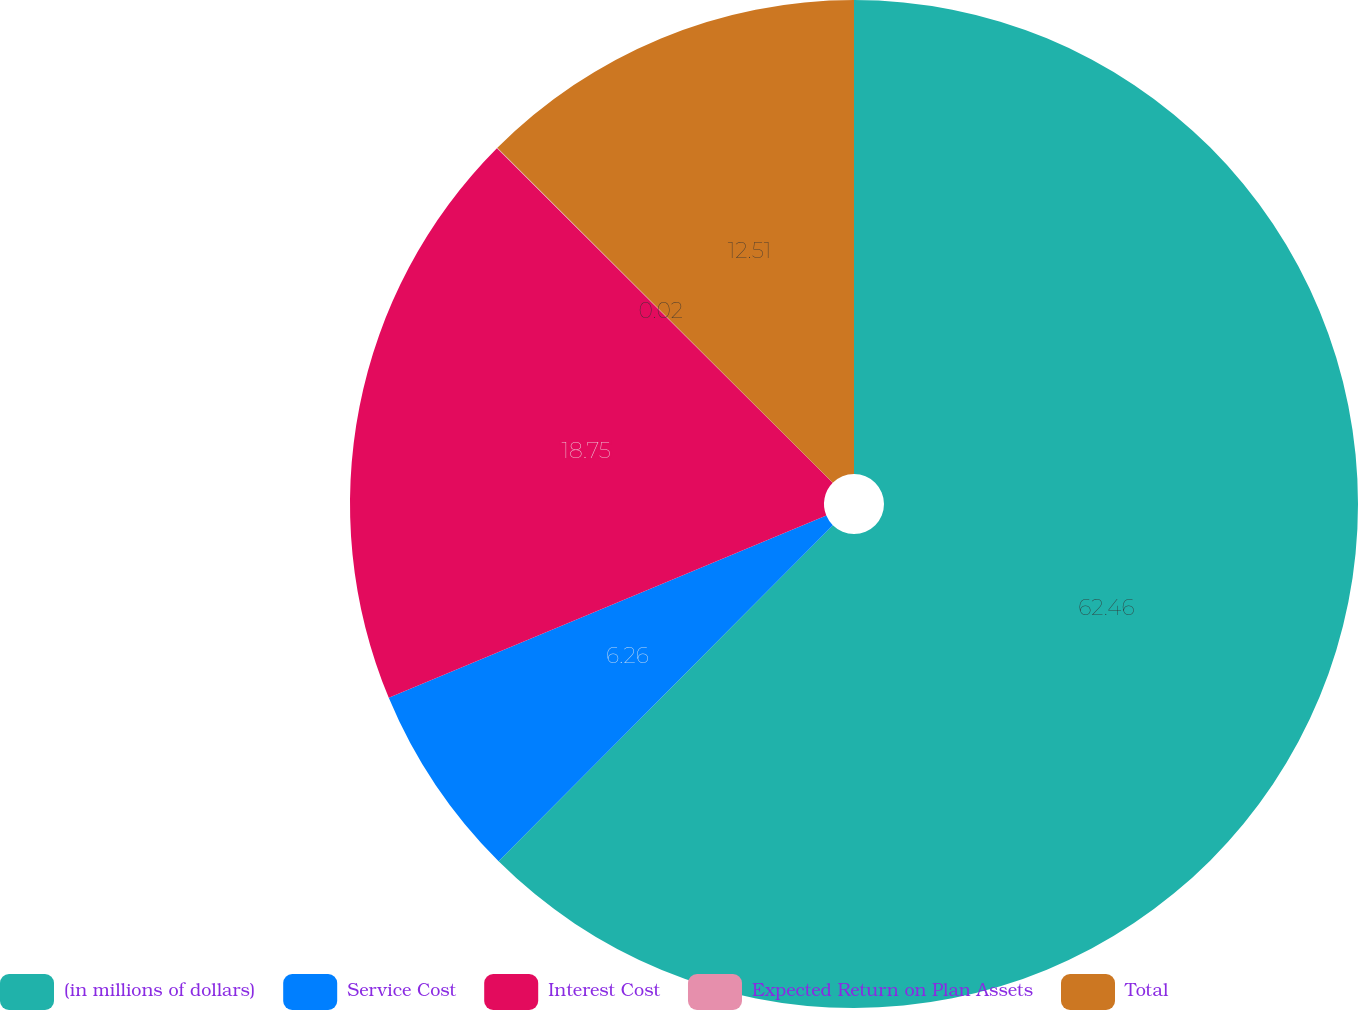<chart> <loc_0><loc_0><loc_500><loc_500><pie_chart><fcel>(in millions of dollars)<fcel>Service Cost<fcel>Interest Cost<fcel>Expected Return on Plan Assets<fcel>Total<nl><fcel>62.45%<fcel>6.26%<fcel>18.75%<fcel>0.02%<fcel>12.51%<nl></chart> 